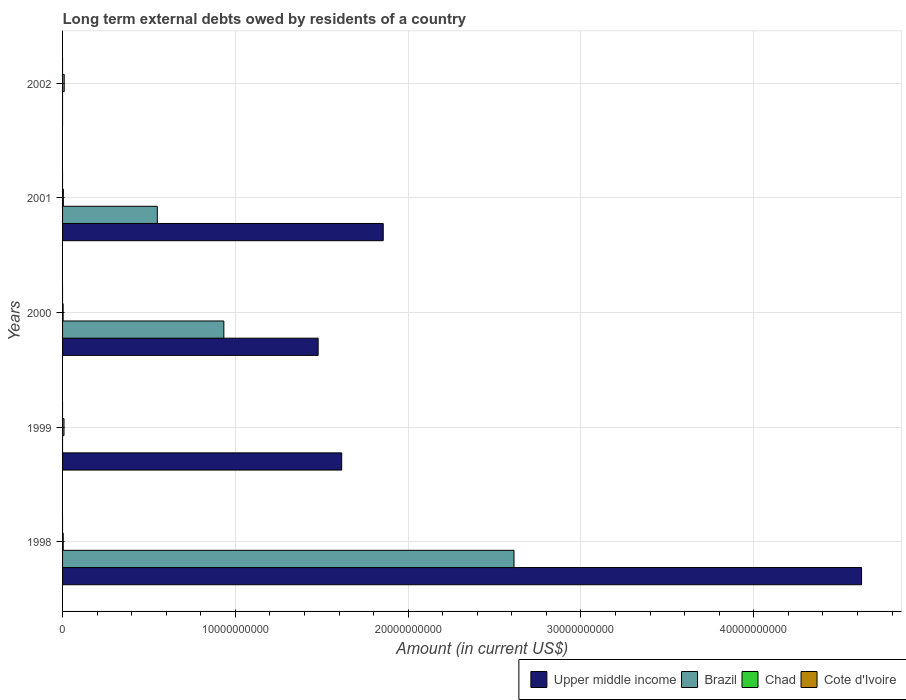How many different coloured bars are there?
Give a very brief answer. 3. Are the number of bars on each tick of the Y-axis equal?
Your response must be concise. No. What is the amount of long-term external debts owed by residents in Chad in 2000?
Provide a short and direct response. 3.26e+07. Across all years, what is the maximum amount of long-term external debts owed by residents in Chad?
Offer a very short reply. 9.56e+07. Across all years, what is the minimum amount of long-term external debts owed by residents in Chad?
Offer a very short reply. 3.26e+07. What is the total amount of long-term external debts owed by residents in Brazil in the graph?
Provide a short and direct response. 4.09e+1. What is the difference between the amount of long-term external debts owed by residents in Upper middle income in 1999 and that in 2000?
Keep it short and to the point. 1.36e+09. What is the difference between the amount of long-term external debts owed by residents in Upper middle income in 2000 and the amount of long-term external debts owed by residents in Chad in 1998?
Offer a terse response. 1.48e+1. What is the average amount of long-term external debts owed by residents in Upper middle income per year?
Ensure brevity in your answer.  1.91e+1. In the year 1999, what is the difference between the amount of long-term external debts owed by residents in Upper middle income and amount of long-term external debts owed by residents in Chad?
Your answer should be very brief. 1.61e+1. What is the ratio of the amount of long-term external debts owed by residents in Chad in 1999 to that in 2002?
Your response must be concise. 0.86. What is the difference between the highest and the second highest amount of long-term external debts owed by residents in Brazil?
Ensure brevity in your answer.  1.68e+1. What is the difference between the highest and the lowest amount of long-term external debts owed by residents in Upper middle income?
Ensure brevity in your answer.  4.62e+1. Is the sum of the amount of long-term external debts owed by residents in Chad in 1998 and 2002 greater than the maximum amount of long-term external debts owed by residents in Upper middle income across all years?
Provide a short and direct response. No. Is it the case that in every year, the sum of the amount of long-term external debts owed by residents in Chad and amount of long-term external debts owed by residents in Brazil is greater than the amount of long-term external debts owed by residents in Cote d'Ivoire?
Keep it short and to the point. Yes. Are all the bars in the graph horizontal?
Your response must be concise. Yes. Are the values on the major ticks of X-axis written in scientific E-notation?
Your answer should be compact. No. Does the graph contain grids?
Offer a terse response. Yes. How are the legend labels stacked?
Offer a very short reply. Horizontal. What is the title of the graph?
Give a very brief answer. Long term external debts owed by residents of a country. Does "Greenland" appear as one of the legend labels in the graph?
Your answer should be compact. No. What is the label or title of the X-axis?
Keep it short and to the point. Amount (in current US$). What is the Amount (in current US$) of Upper middle income in 1998?
Offer a terse response. 4.62e+1. What is the Amount (in current US$) in Brazil in 1998?
Provide a short and direct response. 2.61e+1. What is the Amount (in current US$) in Chad in 1998?
Your answer should be very brief. 3.80e+07. What is the Amount (in current US$) of Cote d'Ivoire in 1998?
Provide a short and direct response. 0. What is the Amount (in current US$) in Upper middle income in 1999?
Your answer should be very brief. 1.62e+1. What is the Amount (in current US$) in Brazil in 1999?
Offer a terse response. 0. What is the Amount (in current US$) of Chad in 1999?
Your answer should be very brief. 8.27e+07. What is the Amount (in current US$) of Upper middle income in 2000?
Give a very brief answer. 1.48e+1. What is the Amount (in current US$) in Brazil in 2000?
Offer a terse response. 9.33e+09. What is the Amount (in current US$) in Chad in 2000?
Your response must be concise. 3.26e+07. What is the Amount (in current US$) in Cote d'Ivoire in 2000?
Provide a succinct answer. 0. What is the Amount (in current US$) of Upper middle income in 2001?
Your answer should be compact. 1.86e+1. What is the Amount (in current US$) of Brazil in 2001?
Your answer should be very brief. 5.48e+09. What is the Amount (in current US$) of Chad in 2001?
Ensure brevity in your answer.  4.51e+07. What is the Amount (in current US$) of Cote d'Ivoire in 2001?
Provide a succinct answer. 0. What is the Amount (in current US$) in Chad in 2002?
Ensure brevity in your answer.  9.56e+07. Across all years, what is the maximum Amount (in current US$) of Upper middle income?
Provide a succinct answer. 4.62e+1. Across all years, what is the maximum Amount (in current US$) of Brazil?
Keep it short and to the point. 2.61e+1. Across all years, what is the maximum Amount (in current US$) in Chad?
Ensure brevity in your answer.  9.56e+07. Across all years, what is the minimum Amount (in current US$) of Brazil?
Offer a very short reply. 0. Across all years, what is the minimum Amount (in current US$) of Chad?
Provide a short and direct response. 3.26e+07. What is the total Amount (in current US$) in Upper middle income in the graph?
Your answer should be very brief. 9.57e+1. What is the total Amount (in current US$) in Brazil in the graph?
Give a very brief answer. 4.09e+1. What is the total Amount (in current US$) in Chad in the graph?
Provide a succinct answer. 2.94e+08. What is the difference between the Amount (in current US$) in Upper middle income in 1998 and that in 1999?
Provide a short and direct response. 3.01e+1. What is the difference between the Amount (in current US$) in Chad in 1998 and that in 1999?
Your answer should be compact. -4.47e+07. What is the difference between the Amount (in current US$) in Upper middle income in 1998 and that in 2000?
Your response must be concise. 3.14e+1. What is the difference between the Amount (in current US$) of Brazil in 1998 and that in 2000?
Offer a terse response. 1.68e+1. What is the difference between the Amount (in current US$) of Chad in 1998 and that in 2000?
Your answer should be very brief. 5.48e+06. What is the difference between the Amount (in current US$) in Upper middle income in 1998 and that in 2001?
Your response must be concise. 2.77e+1. What is the difference between the Amount (in current US$) of Brazil in 1998 and that in 2001?
Give a very brief answer. 2.06e+1. What is the difference between the Amount (in current US$) of Chad in 1998 and that in 2001?
Your response must be concise. -7.03e+06. What is the difference between the Amount (in current US$) of Chad in 1998 and that in 2002?
Keep it short and to the point. -5.76e+07. What is the difference between the Amount (in current US$) of Upper middle income in 1999 and that in 2000?
Your answer should be compact. 1.36e+09. What is the difference between the Amount (in current US$) in Chad in 1999 and that in 2000?
Offer a very short reply. 5.01e+07. What is the difference between the Amount (in current US$) in Upper middle income in 1999 and that in 2001?
Your response must be concise. -2.40e+09. What is the difference between the Amount (in current US$) of Chad in 1999 and that in 2001?
Keep it short and to the point. 3.76e+07. What is the difference between the Amount (in current US$) in Chad in 1999 and that in 2002?
Your answer should be very brief. -1.29e+07. What is the difference between the Amount (in current US$) in Upper middle income in 2000 and that in 2001?
Offer a terse response. -3.77e+09. What is the difference between the Amount (in current US$) in Brazil in 2000 and that in 2001?
Offer a very short reply. 3.85e+09. What is the difference between the Amount (in current US$) of Chad in 2000 and that in 2001?
Ensure brevity in your answer.  -1.25e+07. What is the difference between the Amount (in current US$) in Chad in 2000 and that in 2002?
Offer a terse response. -6.30e+07. What is the difference between the Amount (in current US$) in Chad in 2001 and that in 2002?
Give a very brief answer. -5.05e+07. What is the difference between the Amount (in current US$) in Upper middle income in 1998 and the Amount (in current US$) in Chad in 1999?
Your response must be concise. 4.62e+1. What is the difference between the Amount (in current US$) of Brazil in 1998 and the Amount (in current US$) of Chad in 1999?
Your answer should be compact. 2.60e+1. What is the difference between the Amount (in current US$) of Upper middle income in 1998 and the Amount (in current US$) of Brazil in 2000?
Provide a short and direct response. 3.69e+1. What is the difference between the Amount (in current US$) of Upper middle income in 1998 and the Amount (in current US$) of Chad in 2000?
Offer a terse response. 4.62e+1. What is the difference between the Amount (in current US$) of Brazil in 1998 and the Amount (in current US$) of Chad in 2000?
Provide a succinct answer. 2.61e+1. What is the difference between the Amount (in current US$) in Upper middle income in 1998 and the Amount (in current US$) in Brazil in 2001?
Give a very brief answer. 4.08e+1. What is the difference between the Amount (in current US$) of Upper middle income in 1998 and the Amount (in current US$) of Chad in 2001?
Offer a terse response. 4.62e+1. What is the difference between the Amount (in current US$) of Brazil in 1998 and the Amount (in current US$) of Chad in 2001?
Your answer should be compact. 2.61e+1. What is the difference between the Amount (in current US$) of Upper middle income in 1998 and the Amount (in current US$) of Chad in 2002?
Keep it short and to the point. 4.61e+1. What is the difference between the Amount (in current US$) of Brazil in 1998 and the Amount (in current US$) of Chad in 2002?
Your response must be concise. 2.60e+1. What is the difference between the Amount (in current US$) of Upper middle income in 1999 and the Amount (in current US$) of Brazil in 2000?
Make the answer very short. 6.82e+09. What is the difference between the Amount (in current US$) of Upper middle income in 1999 and the Amount (in current US$) of Chad in 2000?
Give a very brief answer. 1.61e+1. What is the difference between the Amount (in current US$) of Upper middle income in 1999 and the Amount (in current US$) of Brazil in 2001?
Make the answer very short. 1.07e+1. What is the difference between the Amount (in current US$) of Upper middle income in 1999 and the Amount (in current US$) of Chad in 2001?
Make the answer very short. 1.61e+1. What is the difference between the Amount (in current US$) of Upper middle income in 1999 and the Amount (in current US$) of Chad in 2002?
Keep it short and to the point. 1.61e+1. What is the difference between the Amount (in current US$) in Upper middle income in 2000 and the Amount (in current US$) in Brazil in 2001?
Keep it short and to the point. 9.31e+09. What is the difference between the Amount (in current US$) in Upper middle income in 2000 and the Amount (in current US$) in Chad in 2001?
Keep it short and to the point. 1.47e+1. What is the difference between the Amount (in current US$) of Brazil in 2000 and the Amount (in current US$) of Chad in 2001?
Provide a succinct answer. 9.29e+09. What is the difference between the Amount (in current US$) in Upper middle income in 2000 and the Amount (in current US$) in Chad in 2002?
Ensure brevity in your answer.  1.47e+1. What is the difference between the Amount (in current US$) in Brazil in 2000 and the Amount (in current US$) in Chad in 2002?
Provide a succinct answer. 9.24e+09. What is the difference between the Amount (in current US$) of Upper middle income in 2001 and the Amount (in current US$) of Chad in 2002?
Your answer should be very brief. 1.85e+1. What is the difference between the Amount (in current US$) of Brazil in 2001 and the Amount (in current US$) of Chad in 2002?
Provide a succinct answer. 5.39e+09. What is the average Amount (in current US$) in Upper middle income per year?
Your answer should be very brief. 1.91e+1. What is the average Amount (in current US$) in Brazil per year?
Your answer should be compact. 8.19e+09. What is the average Amount (in current US$) in Chad per year?
Offer a very short reply. 5.88e+07. In the year 1998, what is the difference between the Amount (in current US$) of Upper middle income and Amount (in current US$) of Brazil?
Ensure brevity in your answer.  2.01e+1. In the year 1998, what is the difference between the Amount (in current US$) in Upper middle income and Amount (in current US$) in Chad?
Provide a short and direct response. 4.62e+1. In the year 1998, what is the difference between the Amount (in current US$) of Brazil and Amount (in current US$) of Chad?
Offer a terse response. 2.61e+1. In the year 1999, what is the difference between the Amount (in current US$) in Upper middle income and Amount (in current US$) in Chad?
Offer a very short reply. 1.61e+1. In the year 2000, what is the difference between the Amount (in current US$) of Upper middle income and Amount (in current US$) of Brazil?
Offer a very short reply. 5.46e+09. In the year 2000, what is the difference between the Amount (in current US$) in Upper middle income and Amount (in current US$) in Chad?
Your answer should be compact. 1.48e+1. In the year 2000, what is the difference between the Amount (in current US$) in Brazil and Amount (in current US$) in Chad?
Offer a terse response. 9.30e+09. In the year 2001, what is the difference between the Amount (in current US$) in Upper middle income and Amount (in current US$) in Brazil?
Your answer should be very brief. 1.31e+1. In the year 2001, what is the difference between the Amount (in current US$) of Upper middle income and Amount (in current US$) of Chad?
Ensure brevity in your answer.  1.85e+1. In the year 2001, what is the difference between the Amount (in current US$) of Brazil and Amount (in current US$) of Chad?
Your answer should be very brief. 5.44e+09. What is the ratio of the Amount (in current US$) in Upper middle income in 1998 to that in 1999?
Offer a terse response. 2.86. What is the ratio of the Amount (in current US$) in Chad in 1998 to that in 1999?
Your response must be concise. 0.46. What is the ratio of the Amount (in current US$) of Upper middle income in 1998 to that in 2000?
Your answer should be compact. 3.13. What is the ratio of the Amount (in current US$) of Brazil in 1998 to that in 2000?
Ensure brevity in your answer.  2.8. What is the ratio of the Amount (in current US$) of Chad in 1998 to that in 2000?
Ensure brevity in your answer.  1.17. What is the ratio of the Amount (in current US$) of Upper middle income in 1998 to that in 2001?
Make the answer very short. 2.49. What is the ratio of the Amount (in current US$) of Brazil in 1998 to that in 2001?
Give a very brief answer. 4.76. What is the ratio of the Amount (in current US$) of Chad in 1998 to that in 2001?
Your response must be concise. 0.84. What is the ratio of the Amount (in current US$) of Chad in 1998 to that in 2002?
Give a very brief answer. 0.4. What is the ratio of the Amount (in current US$) of Upper middle income in 1999 to that in 2000?
Provide a succinct answer. 1.09. What is the ratio of the Amount (in current US$) of Chad in 1999 to that in 2000?
Your response must be concise. 2.54. What is the ratio of the Amount (in current US$) in Upper middle income in 1999 to that in 2001?
Your response must be concise. 0.87. What is the ratio of the Amount (in current US$) of Chad in 1999 to that in 2001?
Your answer should be compact. 1.83. What is the ratio of the Amount (in current US$) of Chad in 1999 to that in 2002?
Make the answer very short. 0.86. What is the ratio of the Amount (in current US$) in Upper middle income in 2000 to that in 2001?
Your response must be concise. 0.8. What is the ratio of the Amount (in current US$) in Brazil in 2000 to that in 2001?
Ensure brevity in your answer.  1.7. What is the ratio of the Amount (in current US$) of Chad in 2000 to that in 2001?
Your answer should be very brief. 0.72. What is the ratio of the Amount (in current US$) of Chad in 2000 to that in 2002?
Your answer should be compact. 0.34. What is the ratio of the Amount (in current US$) of Chad in 2001 to that in 2002?
Provide a succinct answer. 0.47. What is the difference between the highest and the second highest Amount (in current US$) in Upper middle income?
Offer a terse response. 2.77e+1. What is the difference between the highest and the second highest Amount (in current US$) in Brazil?
Give a very brief answer. 1.68e+1. What is the difference between the highest and the second highest Amount (in current US$) of Chad?
Offer a very short reply. 1.29e+07. What is the difference between the highest and the lowest Amount (in current US$) of Upper middle income?
Give a very brief answer. 4.62e+1. What is the difference between the highest and the lowest Amount (in current US$) in Brazil?
Offer a terse response. 2.61e+1. What is the difference between the highest and the lowest Amount (in current US$) of Chad?
Ensure brevity in your answer.  6.30e+07. 